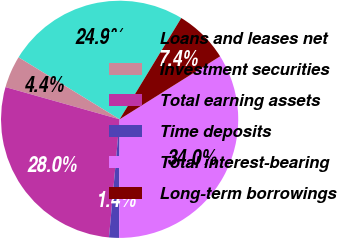Convert chart to OTSL. <chart><loc_0><loc_0><loc_500><loc_500><pie_chart><fcel>Loans and leases net<fcel>Investment securities<fcel>Total earning assets<fcel>Time deposits<fcel>Total interest-bearing<fcel>Long-term borrowings<nl><fcel>24.94%<fcel>4.38%<fcel>27.95%<fcel>1.36%<fcel>33.98%<fcel>7.39%<nl></chart> 